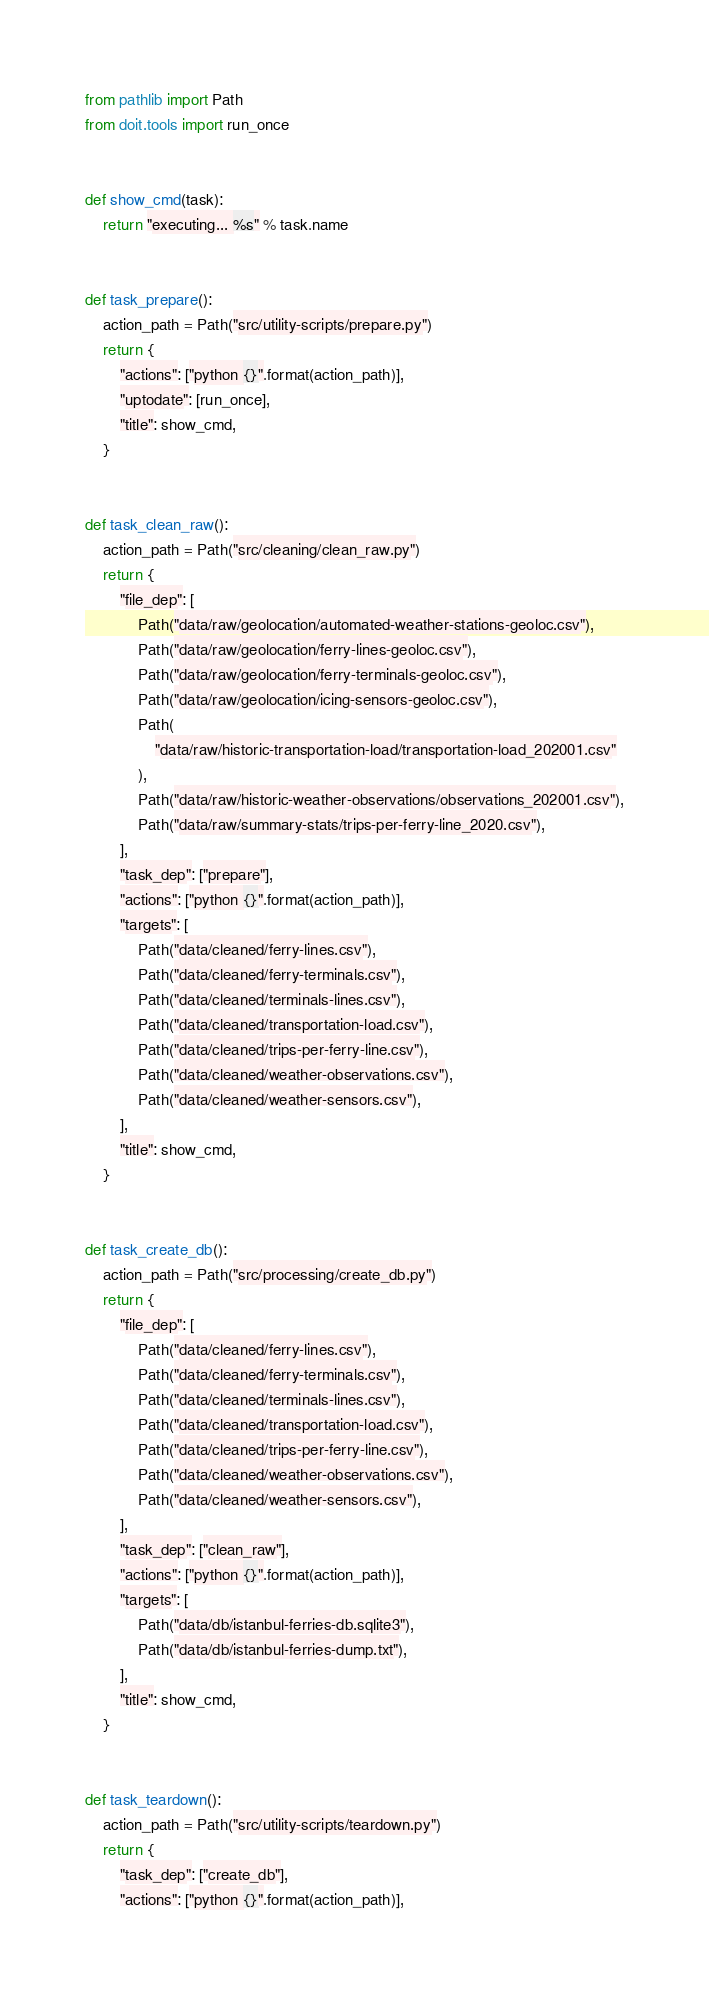<code> <loc_0><loc_0><loc_500><loc_500><_Python_>from pathlib import Path
from doit.tools import run_once


def show_cmd(task):
    return "executing... %s" % task.name


def task_prepare():
    action_path = Path("src/utility-scripts/prepare.py")
    return {
        "actions": ["python {}".format(action_path)],
        "uptodate": [run_once],
        "title": show_cmd,
    }


def task_clean_raw():
    action_path = Path("src/cleaning/clean_raw.py")
    return {
        "file_dep": [
            Path("data/raw/geolocation/automated-weather-stations-geoloc.csv"),
            Path("data/raw/geolocation/ferry-lines-geoloc.csv"),
            Path("data/raw/geolocation/ferry-terminals-geoloc.csv"),
            Path("data/raw/geolocation/icing-sensors-geoloc.csv"),
            Path(
                "data/raw/historic-transportation-load/transportation-load_202001.csv"
            ),
            Path("data/raw/historic-weather-observations/observations_202001.csv"),
            Path("data/raw/summary-stats/trips-per-ferry-line_2020.csv"),
        ],
        "task_dep": ["prepare"],
        "actions": ["python {}".format(action_path)],
        "targets": [
            Path("data/cleaned/ferry-lines.csv"),
            Path("data/cleaned/ferry-terminals.csv"),
            Path("data/cleaned/terminals-lines.csv"),
            Path("data/cleaned/transportation-load.csv"),
            Path("data/cleaned/trips-per-ferry-line.csv"),
            Path("data/cleaned/weather-observations.csv"),
            Path("data/cleaned/weather-sensors.csv"),
        ],
        "title": show_cmd,
    }


def task_create_db():
    action_path = Path("src/processing/create_db.py")
    return {
        "file_dep": [
            Path("data/cleaned/ferry-lines.csv"),
            Path("data/cleaned/ferry-terminals.csv"),
            Path("data/cleaned/terminals-lines.csv"),
            Path("data/cleaned/transportation-load.csv"),
            Path("data/cleaned/trips-per-ferry-line.csv"),
            Path("data/cleaned/weather-observations.csv"),
            Path("data/cleaned/weather-sensors.csv"),
        ],
        "task_dep": ["clean_raw"],
        "actions": ["python {}".format(action_path)],
        "targets": [
            Path("data/db/istanbul-ferries-db.sqlite3"),
            Path("data/db/istanbul-ferries-dump.txt"),
        ],
        "title": show_cmd,
    }


def task_teardown():
    action_path = Path("src/utility-scripts/teardown.py")
    return {
        "task_dep": ["create_db"],
        "actions": ["python {}".format(action_path)],</code> 